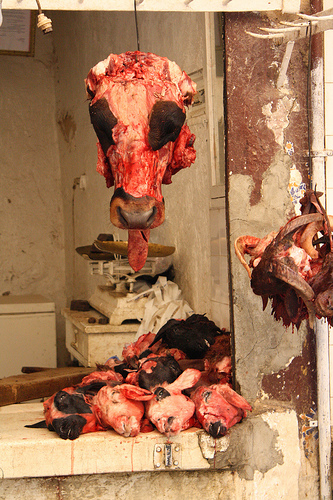<image>
Can you confirm if the animal head is on the floor? No. The animal head is not positioned on the floor. They may be near each other, but the animal head is not supported by or resting on top of the floor. Is the decapitated head above the decapitated head? Yes. The decapitated head is positioned above the decapitated head in the vertical space, higher up in the scene. 